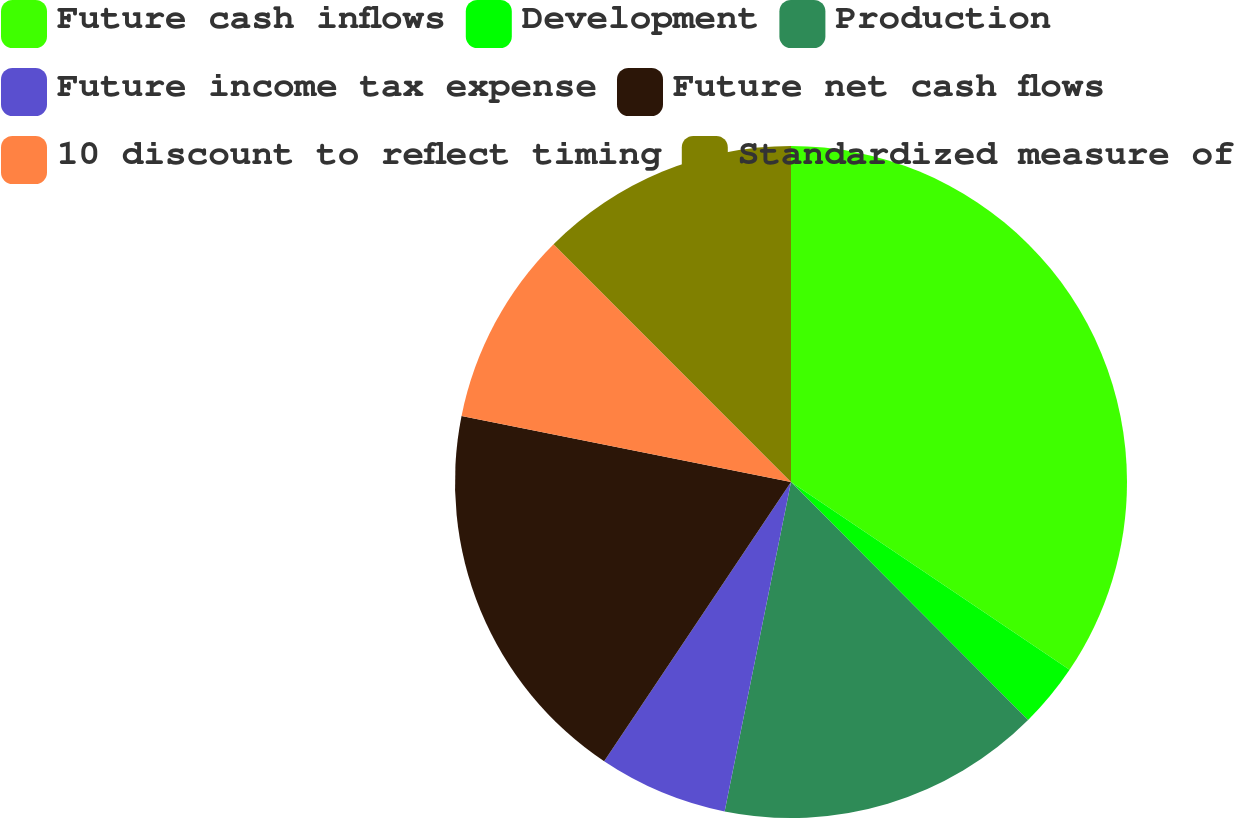Convert chart to OTSL. <chart><loc_0><loc_0><loc_500><loc_500><pie_chart><fcel>Future cash inflows<fcel>Development<fcel>Production<fcel>Future income tax expense<fcel>Future net cash flows<fcel>10 discount to reflect timing<fcel>Standardized measure of<nl><fcel>34.44%<fcel>3.09%<fcel>15.63%<fcel>6.22%<fcel>18.76%<fcel>9.36%<fcel>12.49%<nl></chart> 